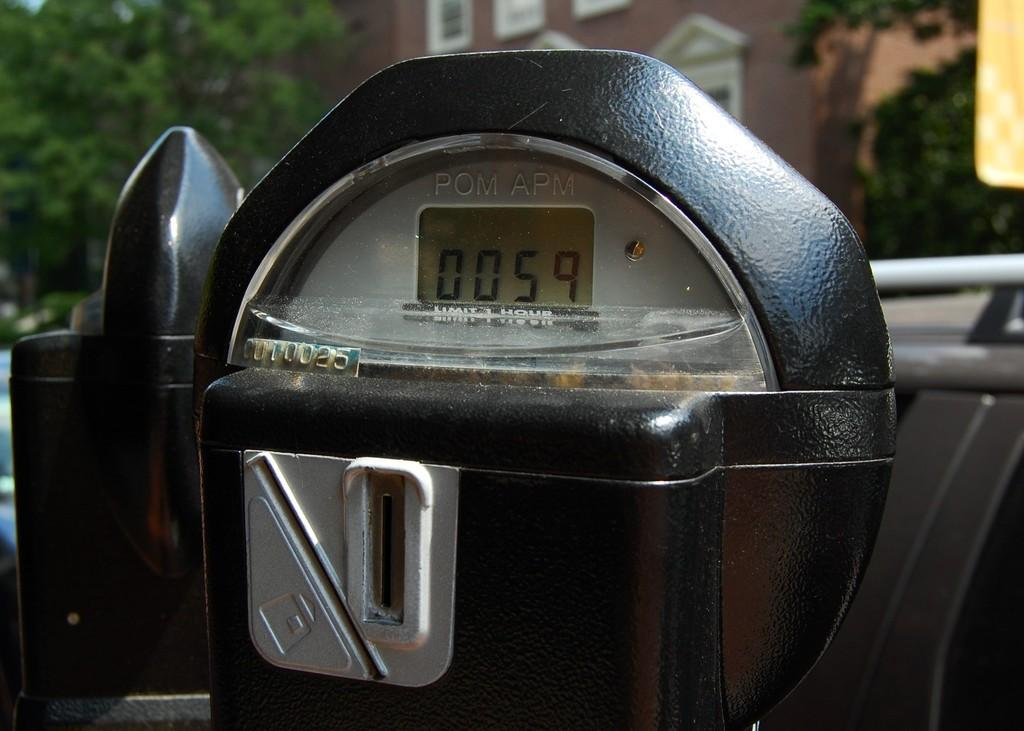Provide a one-sentence caption for the provided image. A parking meter with a display of 0059 and a serial number of 0U10025. 